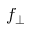Convert formula to latex. <formula><loc_0><loc_0><loc_500><loc_500>f _ { \perp }</formula> 